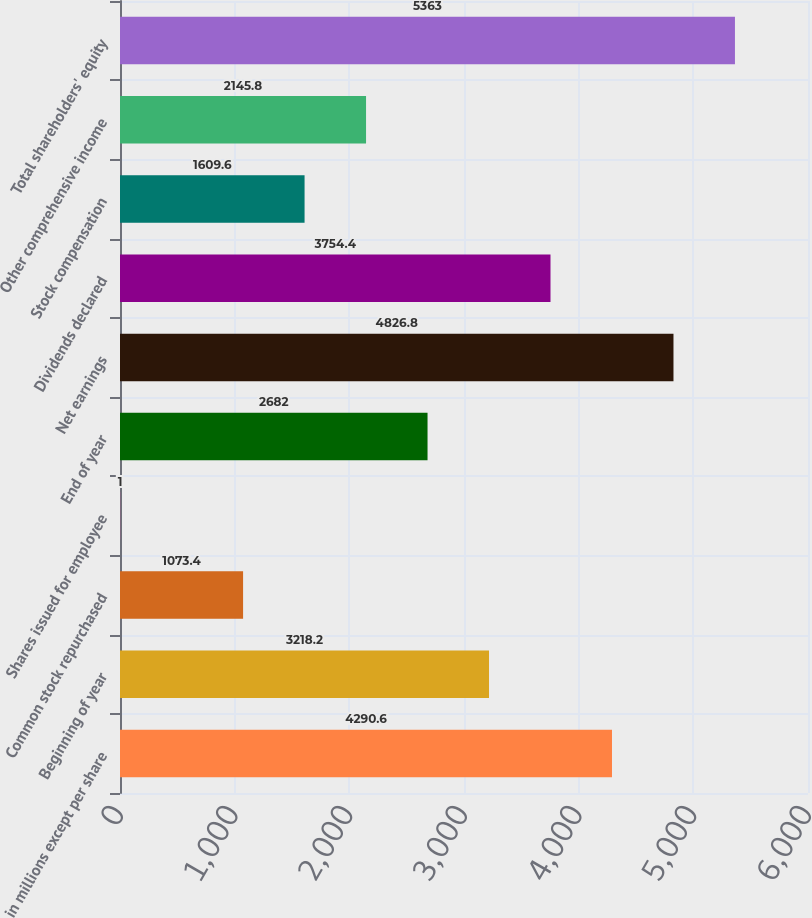Convert chart. <chart><loc_0><loc_0><loc_500><loc_500><bar_chart><fcel>in millions except per share<fcel>Beginning of year<fcel>Common stock repurchased<fcel>Shares issued for employee<fcel>End of year<fcel>Net earnings<fcel>Dividends declared<fcel>Stock compensation<fcel>Other comprehensive income<fcel>Total shareholders' equity<nl><fcel>4290.6<fcel>3218.2<fcel>1073.4<fcel>1<fcel>2682<fcel>4826.8<fcel>3754.4<fcel>1609.6<fcel>2145.8<fcel>5363<nl></chart> 